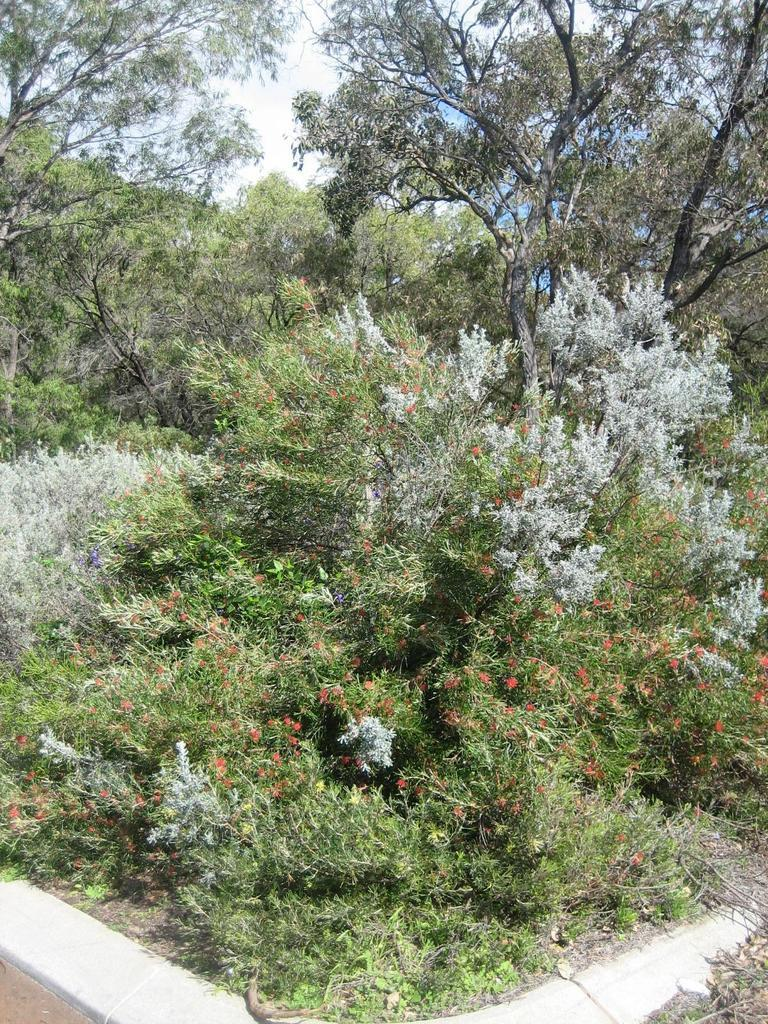What is located in the center of the image? There are plants, flowers, and trees in the center of the image. What type of vegetation can be seen in the image? The image features plants, flowers, and trees. What is the surface at the bottom of the image? There is a floor at the bottom of the image. What is visible at the top of the image? The sky is visible at the top of the image. What type of behavior can be observed in the camera in the image? There is no camera present in the image, so no behavior can be observed. 